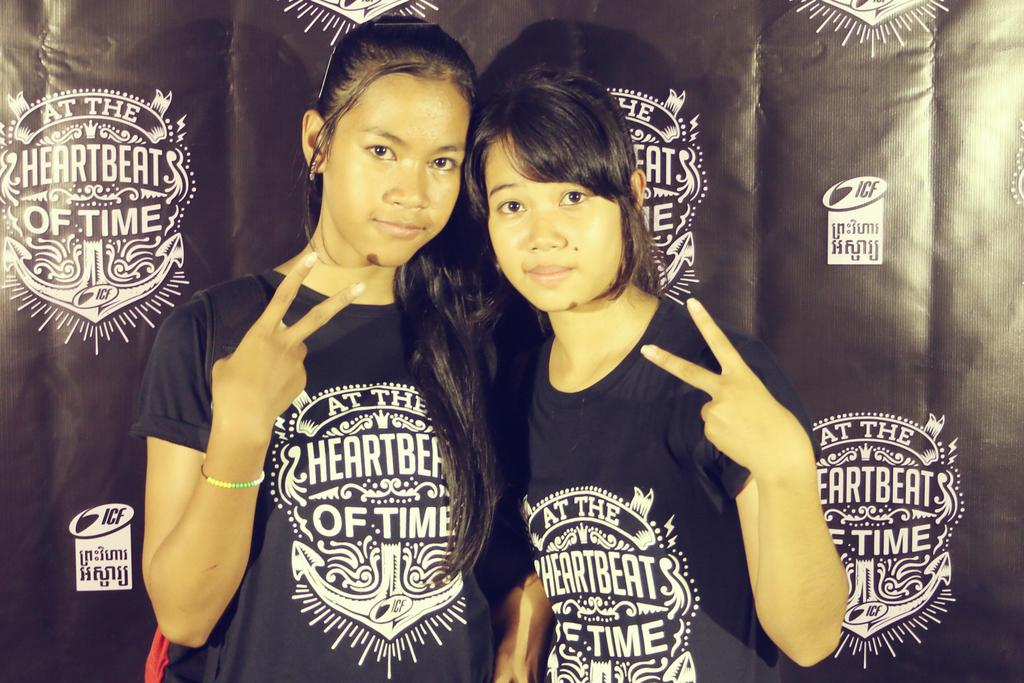How many women are in the picture? There are two women in the picture. What are the women wearing? The women are wearing black T-shirts. What are the women doing in the picture? The women are standing and showing a victory symbol. What can be seen in the background of the picture? There is a banner in the background of the picture. What is written on the banner? The banner has something written on it. Can you see any goats on the hill in the image? There is no hill or goat present in the image. How many legs does the legless creature have in the image? There is no legless creature present in the image. 